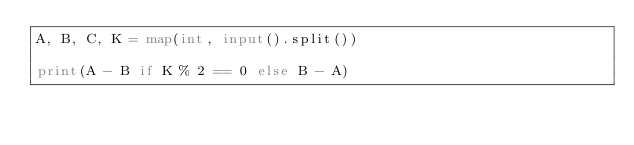Convert code to text. <code><loc_0><loc_0><loc_500><loc_500><_Python_>A, B, C, K = map(int, input().split())

print(A - B if K % 2 == 0 else B - A)
</code> 